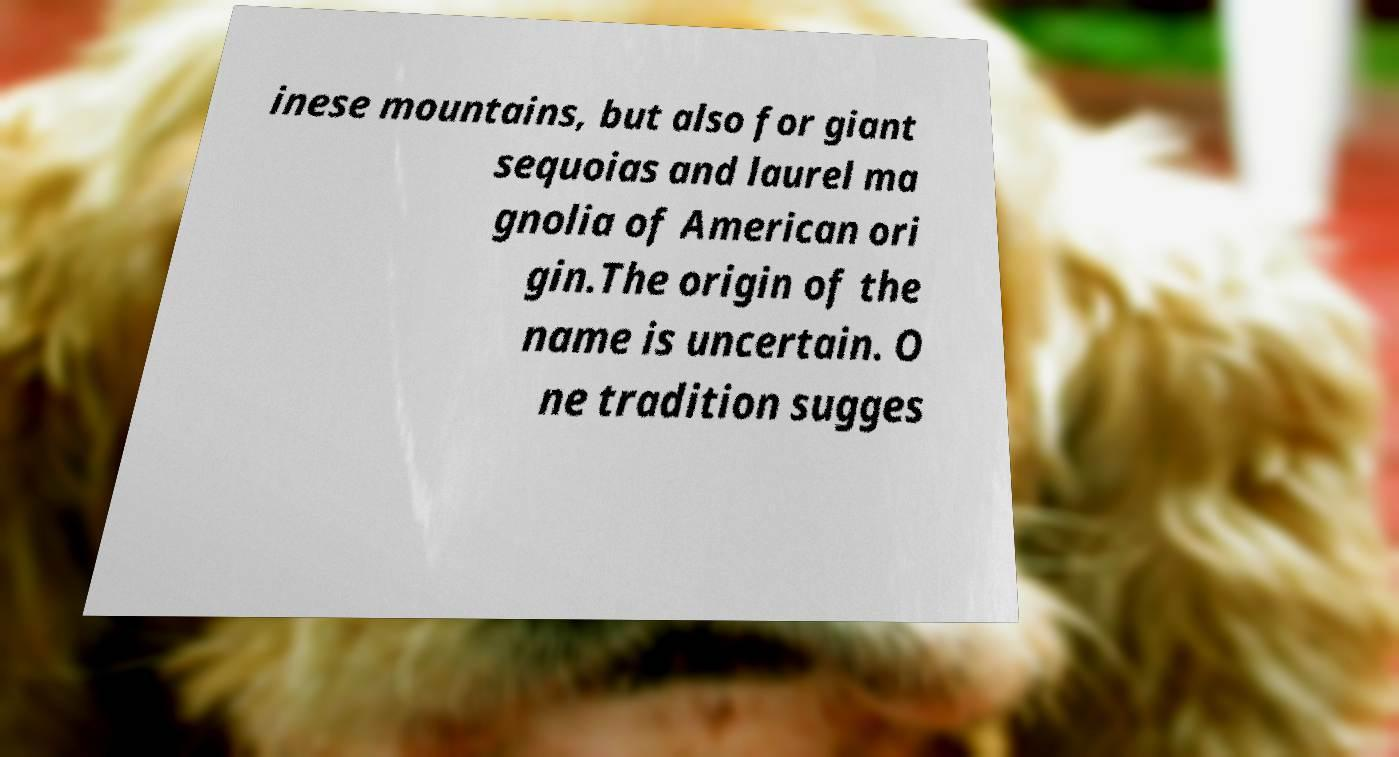For documentation purposes, I need the text within this image transcribed. Could you provide that? inese mountains, but also for giant sequoias and laurel ma gnolia of American ori gin.The origin of the name is uncertain. O ne tradition sugges 